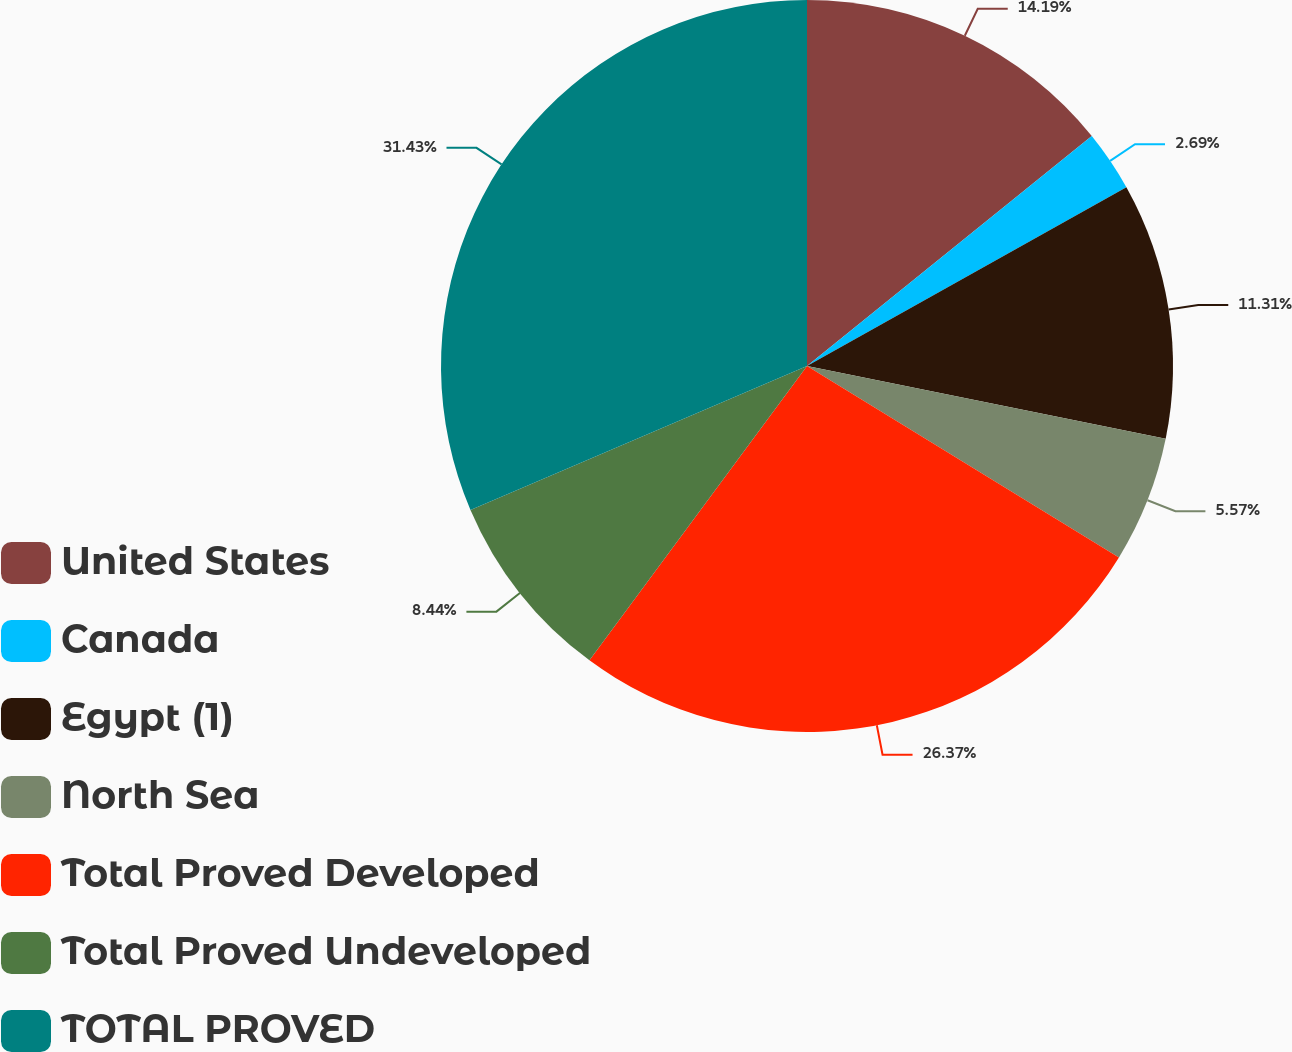Convert chart to OTSL. <chart><loc_0><loc_0><loc_500><loc_500><pie_chart><fcel>United States<fcel>Canada<fcel>Egypt (1)<fcel>North Sea<fcel>Total Proved Developed<fcel>Total Proved Undeveloped<fcel>TOTAL PROVED<nl><fcel>14.19%<fcel>2.69%<fcel>11.31%<fcel>5.57%<fcel>26.37%<fcel>8.44%<fcel>31.43%<nl></chart> 